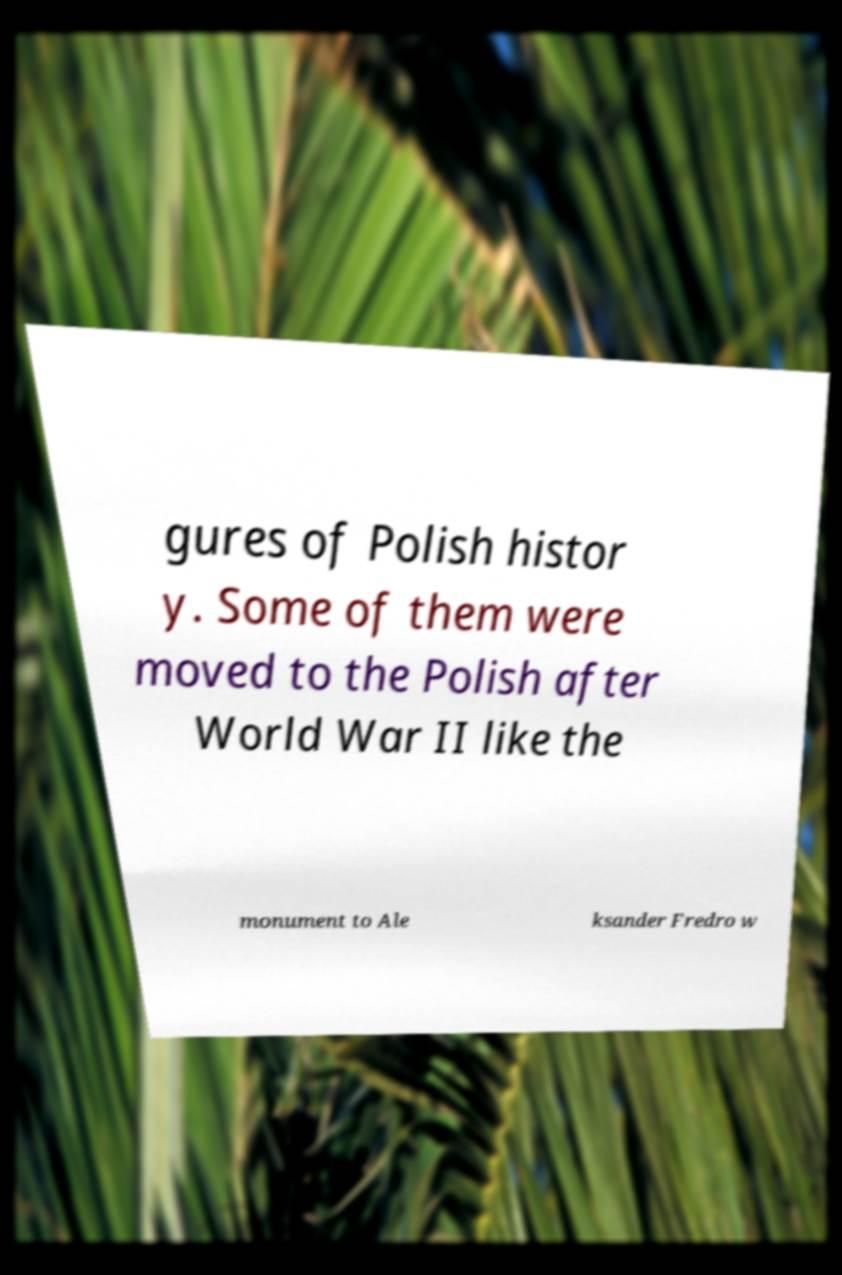Can you accurately transcribe the text from the provided image for me? gures of Polish histor y. Some of them were moved to the Polish after World War II like the monument to Ale ksander Fredro w 